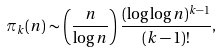Convert formula to latex. <formula><loc_0><loc_0><loc_500><loc_500>\pi _ { k } ( n ) \sim \left ( { \frac { n } { \log n } } \right ) { \frac { ( \log \log n ) ^ { k - 1 } } { ( k - 1 ) ! } } ,</formula> 